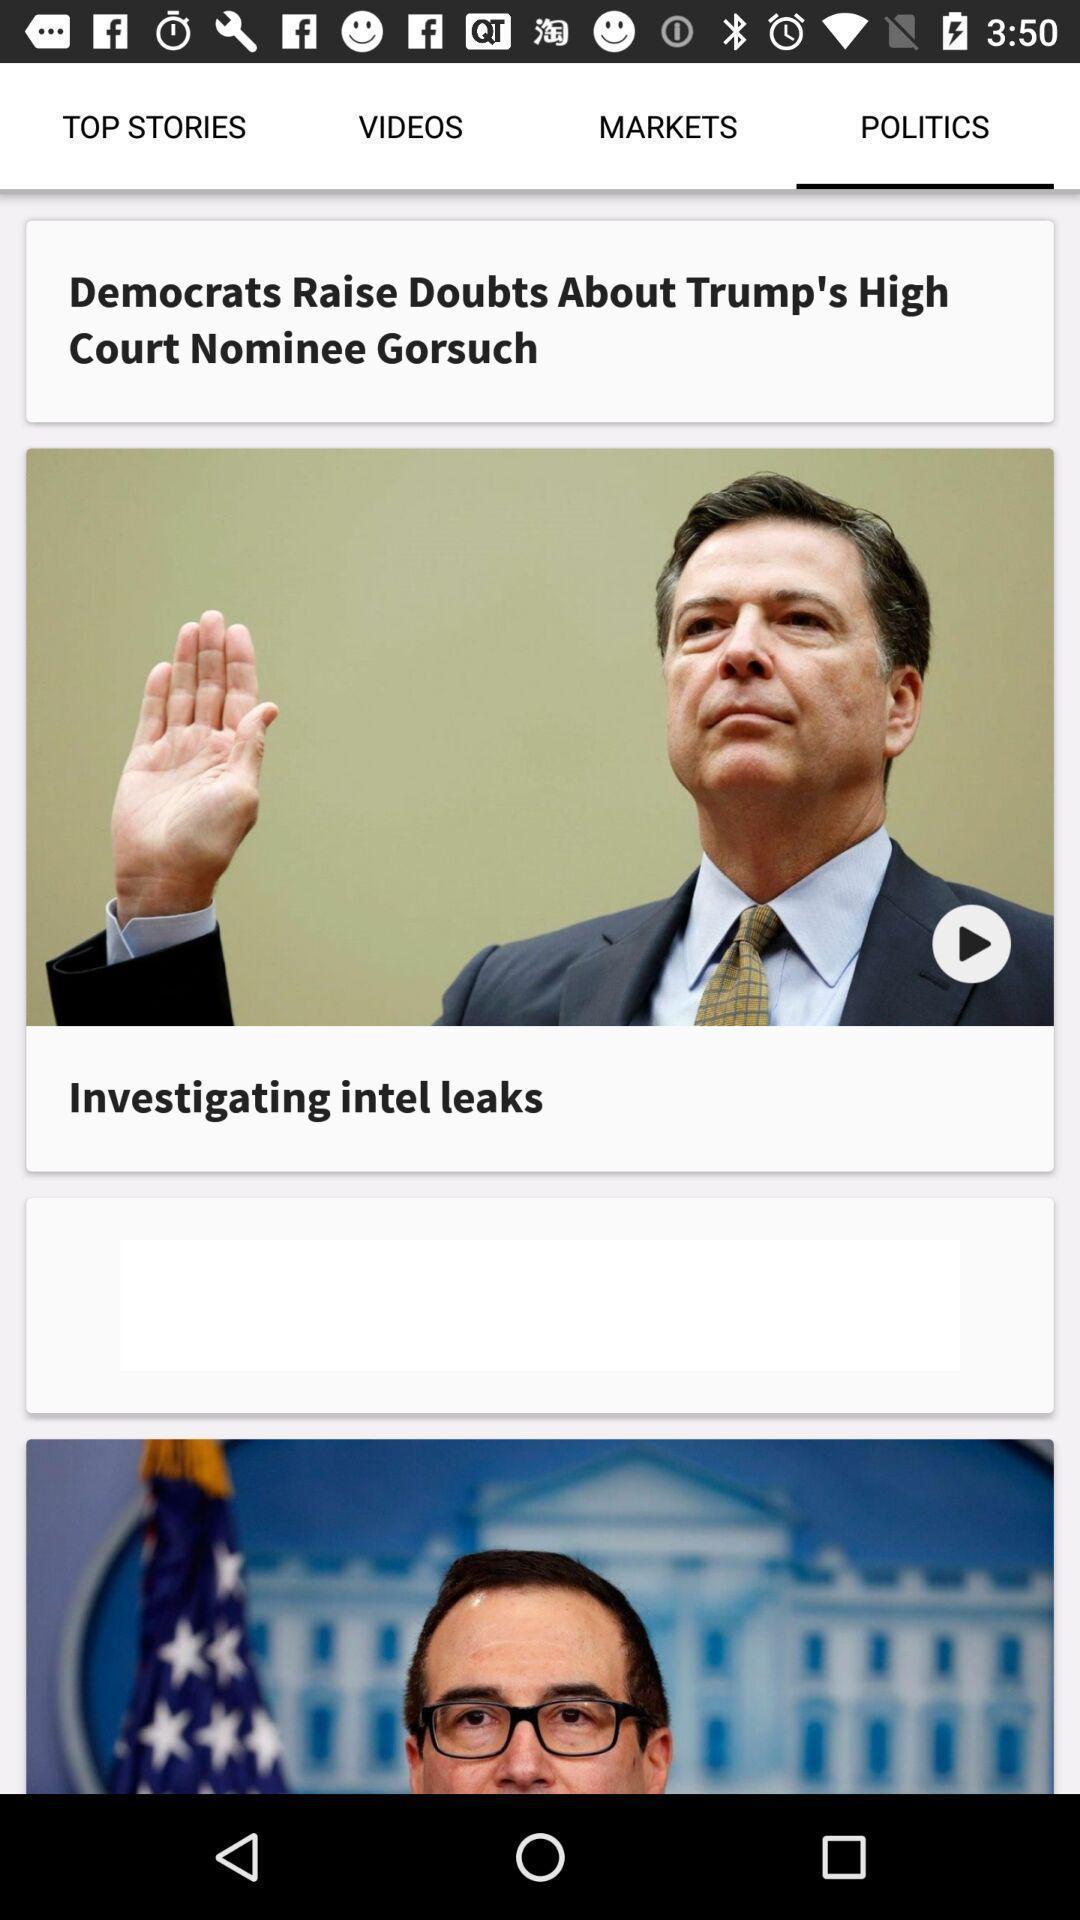Provide a description of this screenshot. Page showing political news on a news app. 